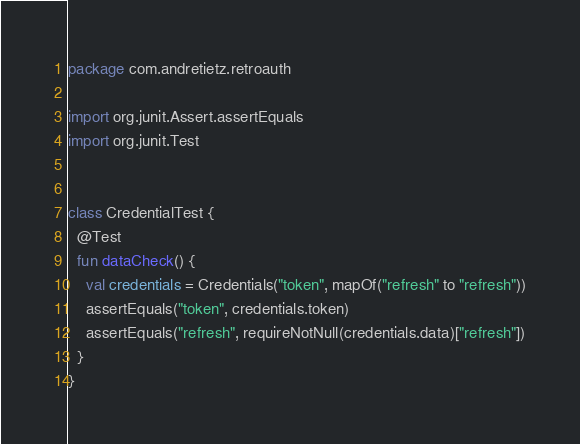<code> <loc_0><loc_0><loc_500><loc_500><_Kotlin_>package com.andretietz.retroauth

import org.junit.Assert.assertEquals
import org.junit.Test


class CredentialTest {
  @Test
  fun dataCheck() {
    val credentials = Credentials("token", mapOf("refresh" to "refresh"))
    assertEquals("token", credentials.token)
    assertEquals("refresh", requireNotNull(credentials.data)["refresh"])
  }
}
</code> 